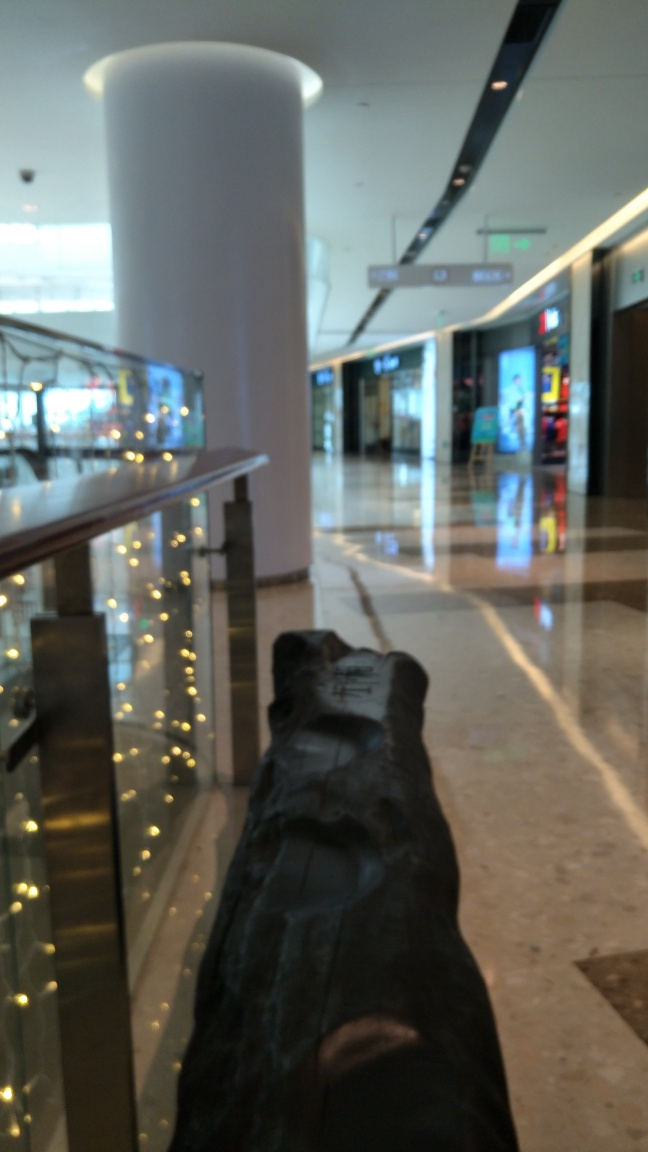Can you tell if the mall is busy at the moment? Based on the lack of people in the scene and the calm atmosphere suggested by the image, it does not seem busy and appears to be a quiet moment in the mall. 